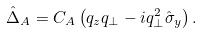Convert formula to latex. <formula><loc_0><loc_0><loc_500><loc_500>\hat { \Delta } _ { A } = C _ { A } \left ( q _ { z } q _ { \perp } - i q ^ { 2 } _ { \perp } \hat { \sigma } _ { y } \right ) .</formula> 